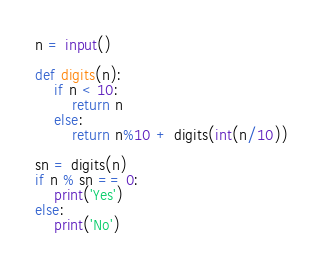<code> <loc_0><loc_0><loc_500><loc_500><_Python_>n = input()

def digits(n):
    if n < 10:
        return n
    else:
        return n%10 + digits(int(n/10))

sn = digits(n)
if n % sn == 0:
    print('Yes')
else:
    print('No')
</code> 